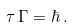Convert formula to latex. <formula><loc_0><loc_0><loc_500><loc_500>\tau \, \Gamma = \hbar { \, } .</formula> 